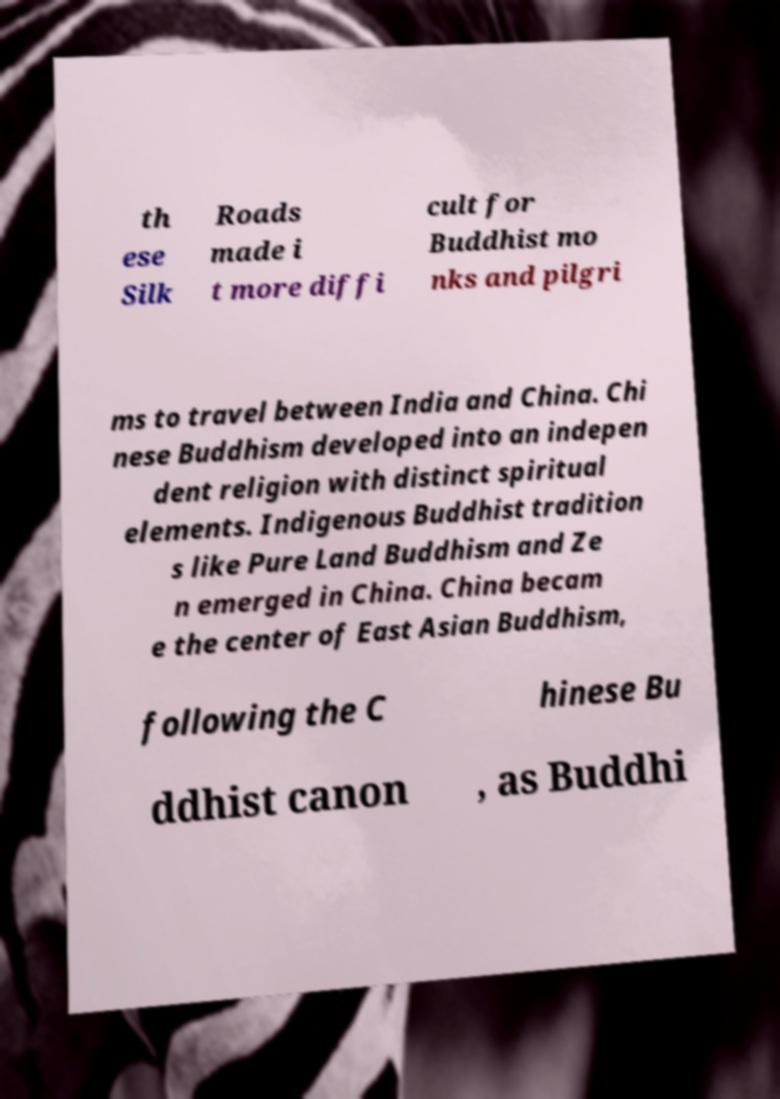I need the written content from this picture converted into text. Can you do that? th ese Silk Roads made i t more diffi cult for Buddhist mo nks and pilgri ms to travel between India and China. Chi nese Buddhism developed into an indepen dent religion with distinct spiritual elements. Indigenous Buddhist tradition s like Pure Land Buddhism and Ze n emerged in China. China becam e the center of East Asian Buddhism, following the C hinese Bu ddhist canon , as Buddhi 